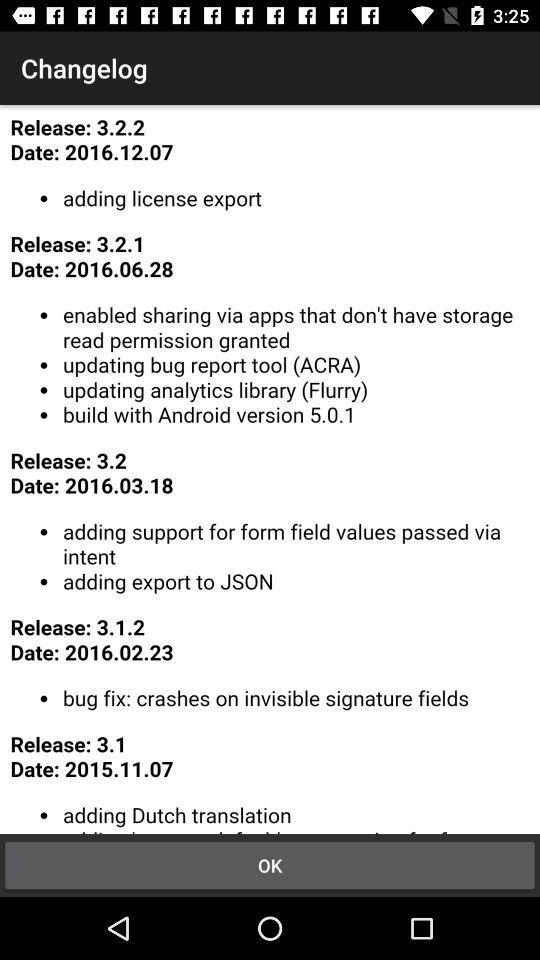On what date is log 3.2.2 released? The date is December 12, 2016. 